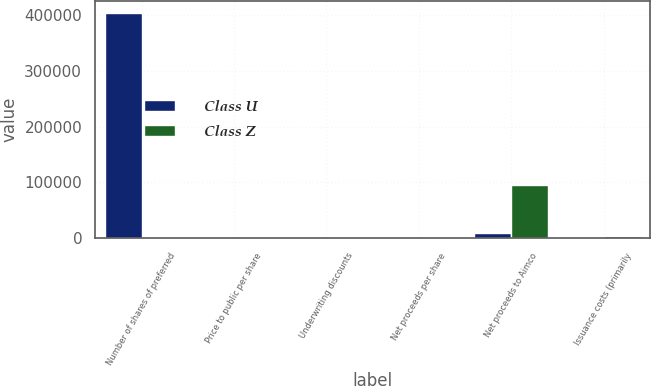Convert chart. <chart><loc_0><loc_0><loc_500><loc_500><stacked_bar_chart><ecel><fcel>Number of shares of preferred<fcel>Price to public per share<fcel>Underwriting discounts<fcel>Net proceeds per share<fcel>Net proceeds to Aimco<fcel>Issuance costs (primarily<nl><fcel>Class U<fcel>405090<fcel>24.78<fcel>0.54<fcel>24.24<fcel>9818<fcel>221<nl><fcel>Class Z<fcel>24.86<fcel>24.86<fcel>0.77<fcel>24.09<fcel>96100<fcel>3300<nl></chart> 